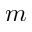<formula> <loc_0><loc_0><loc_500><loc_500>m</formula> 